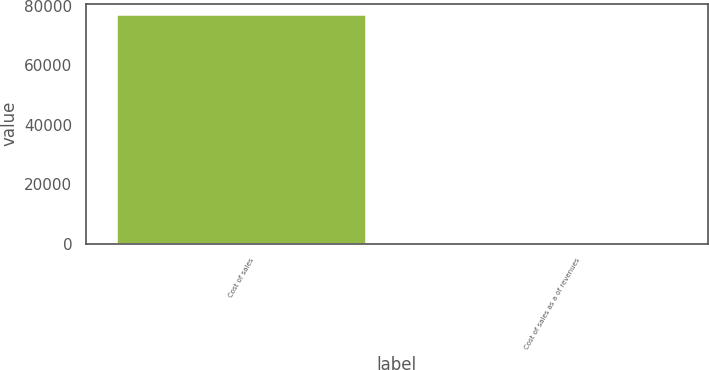Convert chart. <chart><loc_0><loc_0><loc_500><loc_500><bar_chart><fcel>Cost of sales<fcel>Cost of sales as a of revenues<nl><fcel>76752<fcel>84.6<nl></chart> 